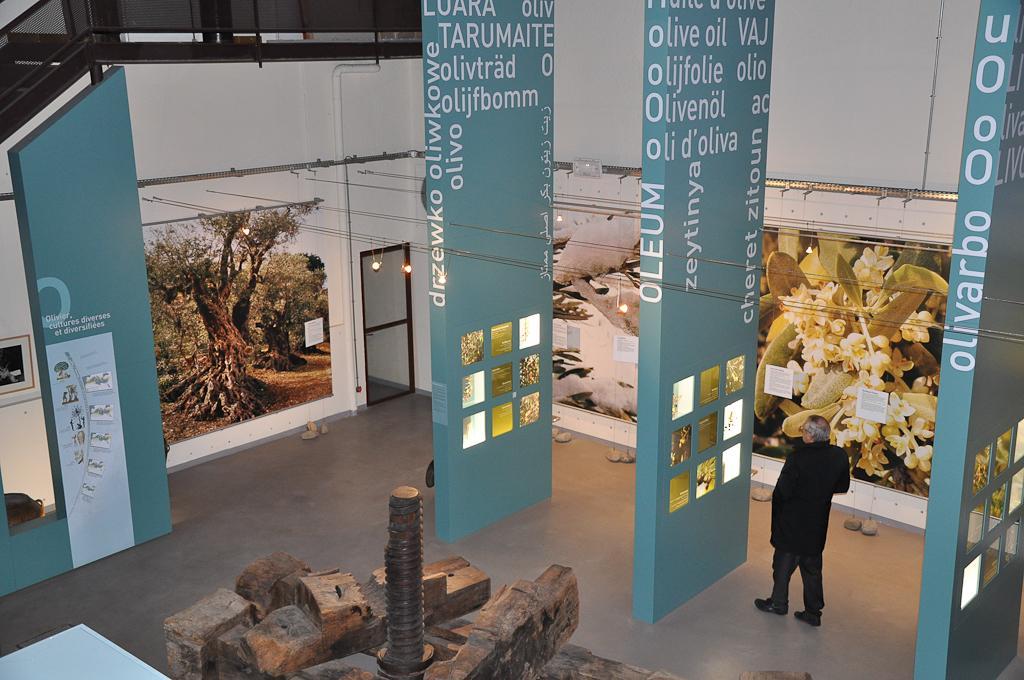Could you give a brief overview of what you see in this image? In the image I can see a person is standing on the floor. I can also see photos and some other objects. In the background I can see a door, lights and some other objects on the wall. In front of the image I can see some objects on the floor. 